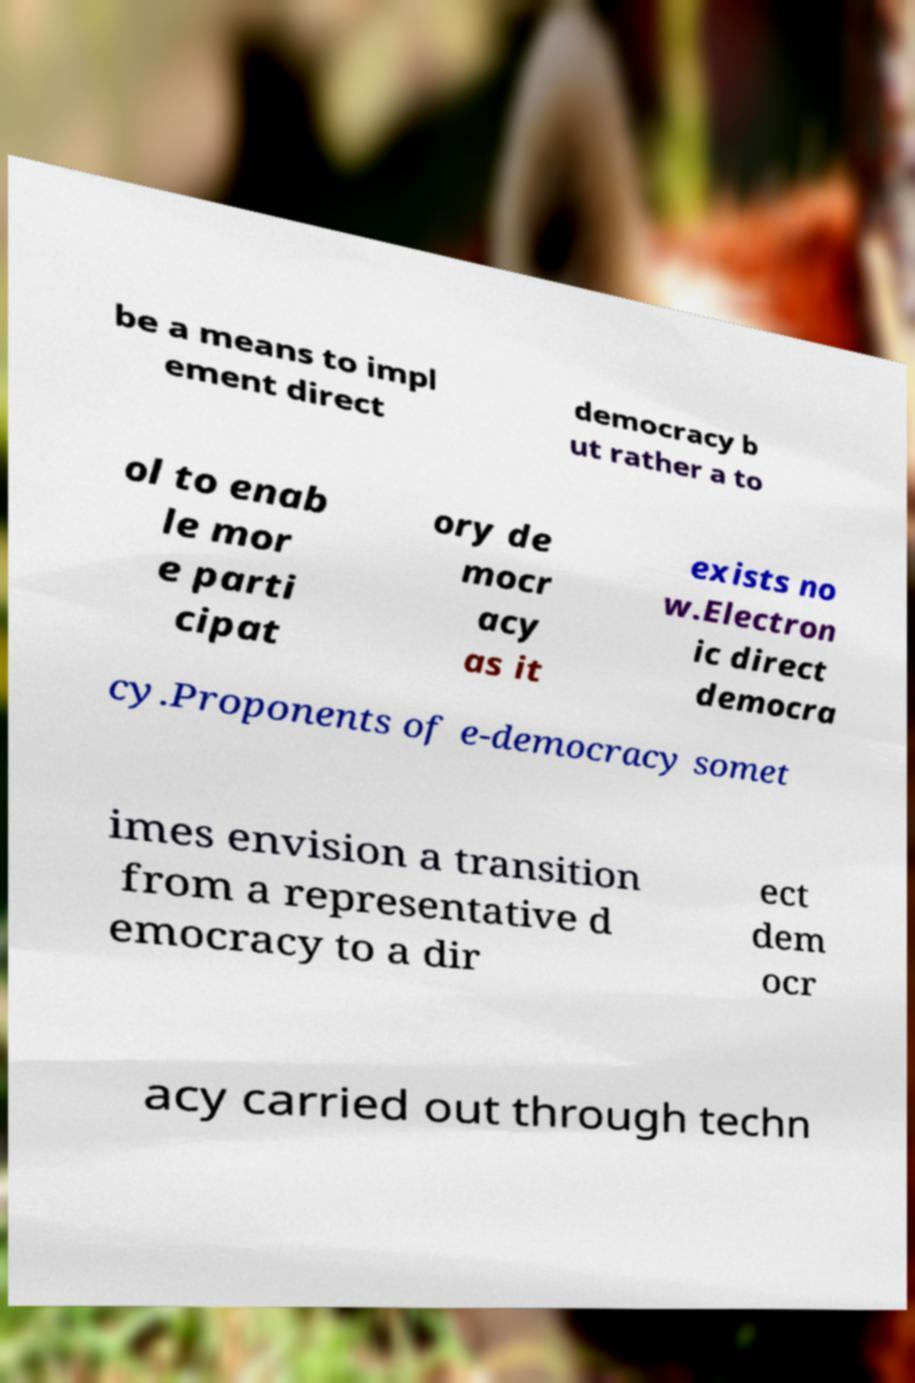Can you accurately transcribe the text from the provided image for me? be a means to impl ement direct democracy b ut rather a to ol to enab le mor e parti cipat ory de mocr acy as it exists no w.Electron ic direct democra cy.Proponents of e-democracy somet imes envision a transition from a representative d emocracy to a dir ect dem ocr acy carried out through techn 